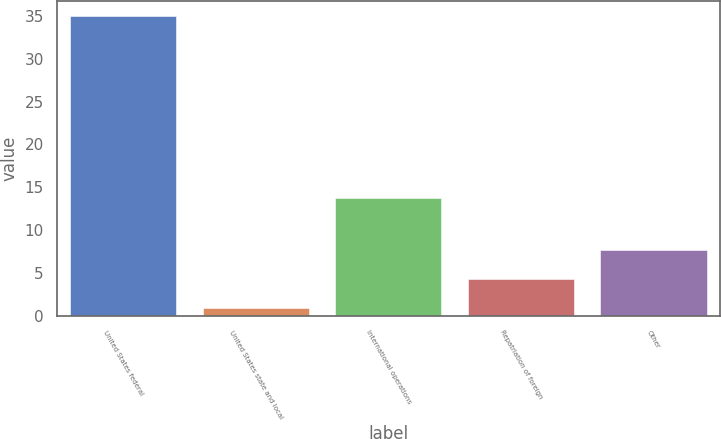Convert chart. <chart><loc_0><loc_0><loc_500><loc_500><bar_chart><fcel>United States federal<fcel>United States state and local<fcel>International operations<fcel>Repatriation of foreign<fcel>Other<nl><fcel>35<fcel>0.9<fcel>13.7<fcel>4.31<fcel>7.72<nl></chart> 